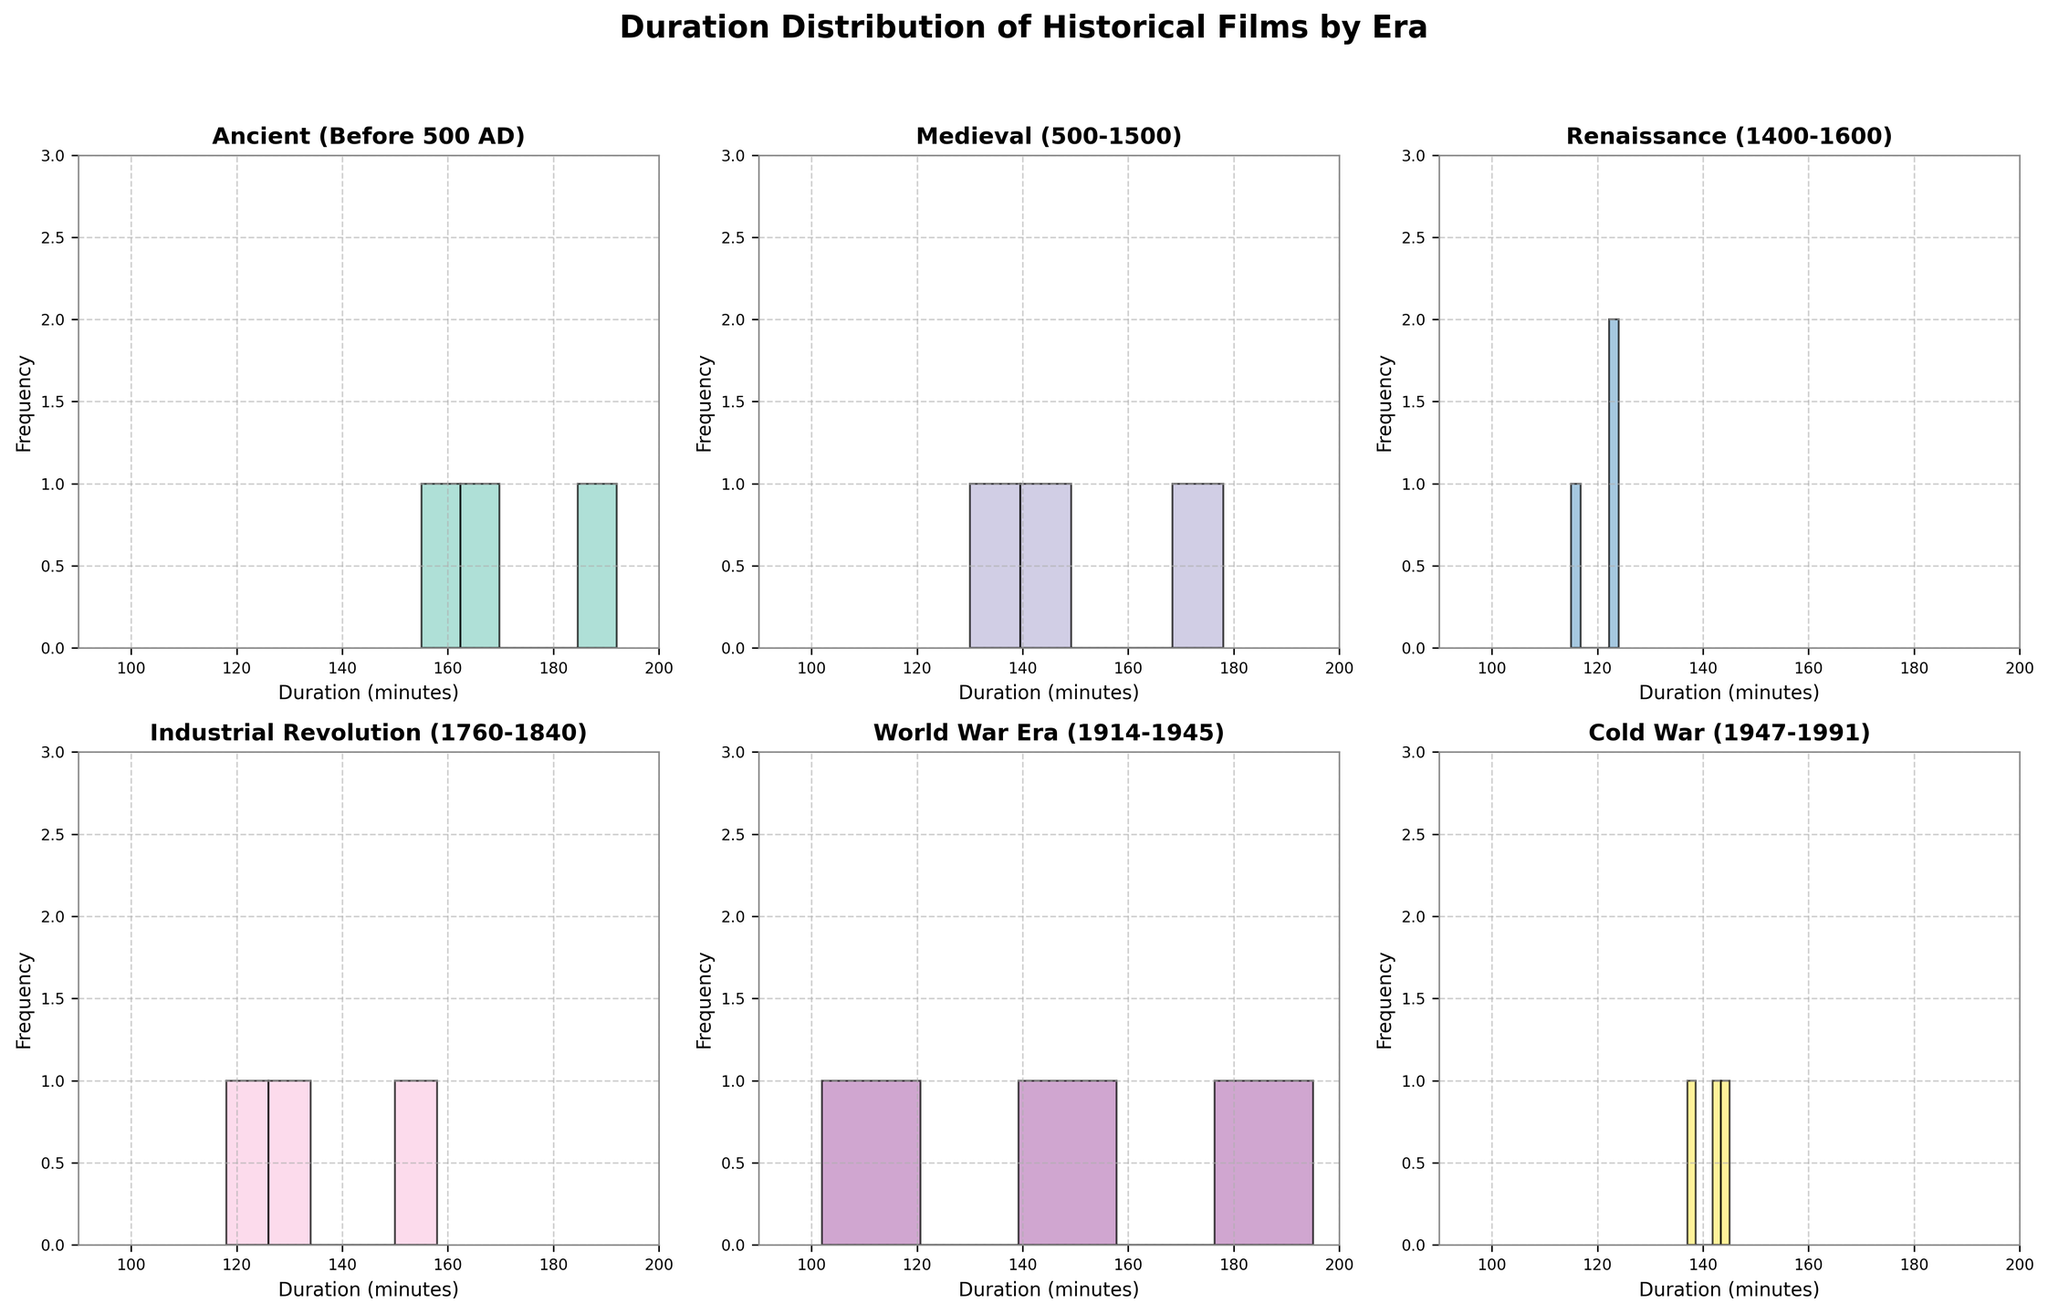What is the title of the figure? The title is displayed at the top center of the figure in bold font. It reads "Duration Distribution of Historical Films by Era".
Answer: Duration Distribution of Historical Films by Era How many eras are represented in the subplots? By looking at the unique subplot titles, we can see that there are six different eras represented.
Answer: Six Which era has the film with the shortest duration? In the 'World War Era (1914-1945)' subplot, the shortest duration shown is 102 minutes for Casablanca.
Answer: World War Era (1914-1945) What is the range of film durations in the 'Ancient (Before 500 AD)' era? The histograms in 'Ancient (Before 500 AD)' show spans from the minimum duration to the maximum duration, which are 155 minutes and 192 minutes respectively. Therefore, the range is 192 - 155.
Answer: 37 minutes Which subplot seems to have the most evenly distributed durations? By observing the histograms, the 'Cold War (1947-1991)' era has durations more evenly distributed across different bins compared to other subplots.
Answer: Cold War (1947-1991) Which era has the highest frequency of films with a duration of around 150 minutes? Checking the height of the bars around the 150-minute mark, 'Medieval (500-1500)' shows two films in this duration range, more than other eras.
Answer: Medieval (500-1500) What is the average duration of films in the 'Renaissance (1400-1600)' era? There are three durations listed in the 'Renaissance (1400-1600)' subplot: 124, 123, and 115 minutes. The average is (124 + 123 + 115) / 3.
Answer: 120.67 minutes How does the film duration distribution in the 'Industrial Revolution (1760-1840)' era compare to 'World War Era (1914-1945)'? Comparing the histogram heights and ranges, 'Industrial Revolution' films have shorter durations on average and are less spread out compared to 'World War Era' films.
Answer: Shorter and less spread out Which era has the most films? By counting the number of bars (each representing a film) in each histogram, 'Cold War (1947-1991)' has the most films, with three entries. Other eras mostly have this number as well, but it can be deduced from context.
Answer: Medieval (500-1500) and Cold War (1947-1991) Which era's histogram shows the least spread in film durations? 'Renaissance (1400-1600)' shows the least spread; the film durations are very close to each other with a small range compared to other eras.
Answer: Renaissance (1400-1600) 